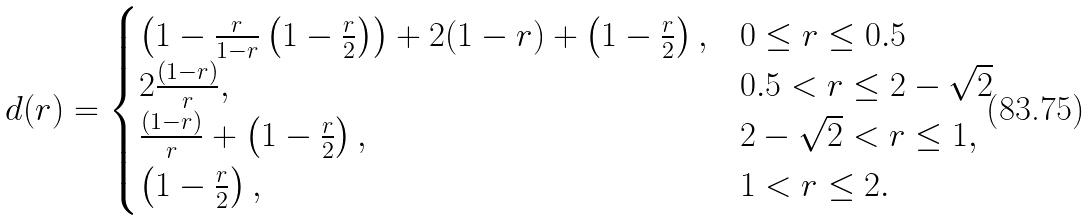Convert formula to latex. <formula><loc_0><loc_0><loc_500><loc_500>d ( r ) = \begin{cases} \left ( 1 - \frac { r } { 1 - r } \left ( 1 - \frac { r } { 2 } \right ) \right ) + 2 ( 1 - r ) + \left ( 1 - \frac { r } { 2 } \right ) , & 0 \leq r \leq 0 . 5 \\ 2 \frac { ( 1 - r ) } { r } , & 0 . 5 < r \leq 2 - \sqrt { 2 } \\ \frac { ( 1 - r ) } { r } + \left ( 1 - \frac { r } { 2 } \right ) , & 2 - \sqrt { 2 } < r \leq 1 , \\ \left ( 1 - \frac { r } { 2 } \right ) , & 1 < r \leq 2 . \end{cases}</formula> 